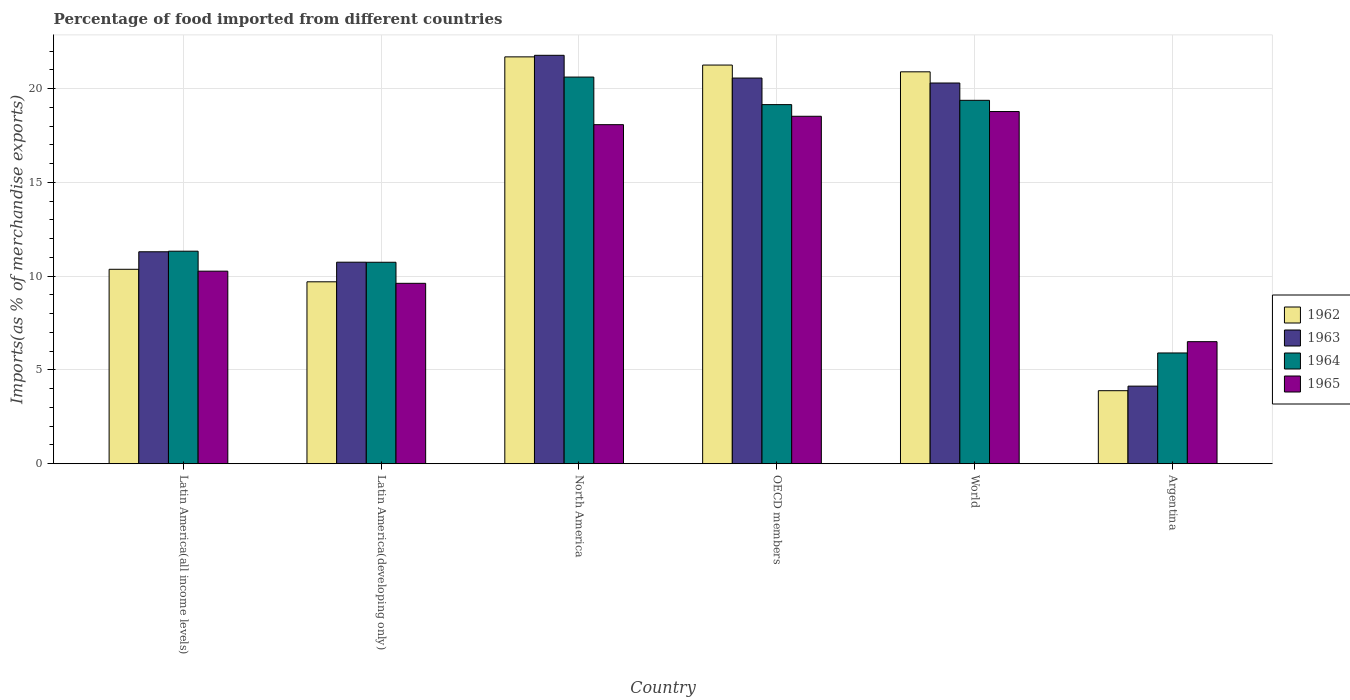How many bars are there on the 3rd tick from the left?
Make the answer very short. 4. What is the label of the 2nd group of bars from the left?
Give a very brief answer. Latin America(developing only). In how many cases, is the number of bars for a given country not equal to the number of legend labels?
Provide a short and direct response. 0. What is the percentage of imports to different countries in 1963 in North America?
Keep it short and to the point. 21.77. Across all countries, what is the maximum percentage of imports to different countries in 1965?
Give a very brief answer. 18.77. Across all countries, what is the minimum percentage of imports to different countries in 1965?
Give a very brief answer. 6.51. In which country was the percentage of imports to different countries in 1962 maximum?
Provide a short and direct response. North America. In which country was the percentage of imports to different countries in 1963 minimum?
Your answer should be compact. Argentina. What is the total percentage of imports to different countries in 1963 in the graph?
Your response must be concise. 88.8. What is the difference between the percentage of imports to different countries in 1963 in North America and that in World?
Offer a very short reply. 1.48. What is the difference between the percentage of imports to different countries in 1963 in Argentina and the percentage of imports to different countries in 1964 in OECD members?
Offer a very short reply. -15.01. What is the average percentage of imports to different countries in 1965 per country?
Give a very brief answer. 13.63. What is the difference between the percentage of imports to different countries of/in 1963 and percentage of imports to different countries of/in 1962 in OECD members?
Provide a short and direct response. -0.69. In how many countries, is the percentage of imports to different countries in 1965 greater than 12 %?
Your response must be concise. 3. What is the ratio of the percentage of imports to different countries in 1965 in Latin America(developing only) to that in World?
Offer a very short reply. 0.51. Is the difference between the percentage of imports to different countries in 1963 in Argentina and Latin America(developing only) greater than the difference between the percentage of imports to different countries in 1962 in Argentina and Latin America(developing only)?
Offer a very short reply. No. What is the difference between the highest and the second highest percentage of imports to different countries in 1965?
Your answer should be compact. -0.7. What is the difference between the highest and the lowest percentage of imports to different countries in 1965?
Ensure brevity in your answer.  12.27. Is it the case that in every country, the sum of the percentage of imports to different countries in 1962 and percentage of imports to different countries in 1965 is greater than the sum of percentage of imports to different countries in 1963 and percentage of imports to different countries in 1964?
Offer a very short reply. No. What does the 3rd bar from the left in Latin America(developing only) represents?
Make the answer very short. 1964. What does the 3rd bar from the right in Latin America(developing only) represents?
Provide a short and direct response. 1963. Is it the case that in every country, the sum of the percentage of imports to different countries in 1963 and percentage of imports to different countries in 1964 is greater than the percentage of imports to different countries in 1965?
Offer a terse response. Yes. Are all the bars in the graph horizontal?
Ensure brevity in your answer.  No. Are the values on the major ticks of Y-axis written in scientific E-notation?
Provide a short and direct response. No. How many legend labels are there?
Give a very brief answer. 4. What is the title of the graph?
Ensure brevity in your answer.  Percentage of food imported from different countries. What is the label or title of the X-axis?
Give a very brief answer. Country. What is the label or title of the Y-axis?
Ensure brevity in your answer.  Imports(as % of merchandise exports). What is the Imports(as % of merchandise exports) of 1962 in Latin America(all income levels)?
Make the answer very short. 10.36. What is the Imports(as % of merchandise exports) of 1963 in Latin America(all income levels)?
Your answer should be very brief. 11.3. What is the Imports(as % of merchandise exports) of 1964 in Latin America(all income levels)?
Provide a succinct answer. 11.33. What is the Imports(as % of merchandise exports) in 1965 in Latin America(all income levels)?
Ensure brevity in your answer.  10.26. What is the Imports(as % of merchandise exports) of 1962 in Latin America(developing only)?
Offer a very short reply. 9.7. What is the Imports(as % of merchandise exports) of 1963 in Latin America(developing only)?
Offer a terse response. 10.74. What is the Imports(as % of merchandise exports) in 1964 in Latin America(developing only)?
Keep it short and to the point. 10.74. What is the Imports(as % of merchandise exports) in 1965 in Latin America(developing only)?
Offer a terse response. 9.62. What is the Imports(as % of merchandise exports) of 1962 in North America?
Ensure brevity in your answer.  21.69. What is the Imports(as % of merchandise exports) in 1963 in North America?
Ensure brevity in your answer.  21.77. What is the Imports(as % of merchandise exports) in 1964 in North America?
Keep it short and to the point. 20.61. What is the Imports(as % of merchandise exports) in 1965 in North America?
Offer a terse response. 18.07. What is the Imports(as % of merchandise exports) in 1962 in OECD members?
Ensure brevity in your answer.  21.25. What is the Imports(as % of merchandise exports) in 1963 in OECD members?
Offer a terse response. 20.56. What is the Imports(as % of merchandise exports) of 1964 in OECD members?
Your response must be concise. 19.14. What is the Imports(as % of merchandise exports) in 1965 in OECD members?
Keep it short and to the point. 18.52. What is the Imports(as % of merchandise exports) in 1962 in World?
Provide a succinct answer. 20.89. What is the Imports(as % of merchandise exports) of 1963 in World?
Keep it short and to the point. 20.29. What is the Imports(as % of merchandise exports) of 1964 in World?
Make the answer very short. 19.37. What is the Imports(as % of merchandise exports) in 1965 in World?
Your answer should be compact. 18.77. What is the Imports(as % of merchandise exports) of 1962 in Argentina?
Make the answer very short. 3.89. What is the Imports(as % of merchandise exports) in 1963 in Argentina?
Give a very brief answer. 4.14. What is the Imports(as % of merchandise exports) in 1964 in Argentina?
Your answer should be very brief. 5.91. What is the Imports(as % of merchandise exports) of 1965 in Argentina?
Your answer should be compact. 6.51. Across all countries, what is the maximum Imports(as % of merchandise exports) in 1962?
Keep it short and to the point. 21.69. Across all countries, what is the maximum Imports(as % of merchandise exports) in 1963?
Give a very brief answer. 21.77. Across all countries, what is the maximum Imports(as % of merchandise exports) in 1964?
Provide a short and direct response. 20.61. Across all countries, what is the maximum Imports(as % of merchandise exports) of 1965?
Make the answer very short. 18.77. Across all countries, what is the minimum Imports(as % of merchandise exports) of 1962?
Give a very brief answer. 3.89. Across all countries, what is the minimum Imports(as % of merchandise exports) of 1963?
Keep it short and to the point. 4.14. Across all countries, what is the minimum Imports(as % of merchandise exports) in 1964?
Keep it short and to the point. 5.91. Across all countries, what is the minimum Imports(as % of merchandise exports) in 1965?
Offer a very short reply. 6.51. What is the total Imports(as % of merchandise exports) in 1962 in the graph?
Your response must be concise. 87.79. What is the total Imports(as % of merchandise exports) of 1963 in the graph?
Make the answer very short. 88.8. What is the total Imports(as % of merchandise exports) of 1964 in the graph?
Keep it short and to the point. 87.1. What is the total Imports(as % of merchandise exports) of 1965 in the graph?
Keep it short and to the point. 81.76. What is the difference between the Imports(as % of merchandise exports) in 1962 in Latin America(all income levels) and that in Latin America(developing only)?
Ensure brevity in your answer.  0.67. What is the difference between the Imports(as % of merchandise exports) in 1963 in Latin America(all income levels) and that in Latin America(developing only)?
Provide a short and direct response. 0.56. What is the difference between the Imports(as % of merchandise exports) in 1964 in Latin America(all income levels) and that in Latin America(developing only)?
Provide a short and direct response. 0.59. What is the difference between the Imports(as % of merchandise exports) in 1965 in Latin America(all income levels) and that in Latin America(developing only)?
Provide a short and direct response. 0.65. What is the difference between the Imports(as % of merchandise exports) in 1962 in Latin America(all income levels) and that in North America?
Your answer should be compact. -11.32. What is the difference between the Imports(as % of merchandise exports) in 1963 in Latin America(all income levels) and that in North America?
Your response must be concise. -10.47. What is the difference between the Imports(as % of merchandise exports) in 1964 in Latin America(all income levels) and that in North America?
Offer a very short reply. -9.28. What is the difference between the Imports(as % of merchandise exports) in 1965 in Latin America(all income levels) and that in North America?
Offer a terse response. -7.81. What is the difference between the Imports(as % of merchandise exports) in 1962 in Latin America(all income levels) and that in OECD members?
Ensure brevity in your answer.  -10.89. What is the difference between the Imports(as % of merchandise exports) in 1963 in Latin America(all income levels) and that in OECD members?
Your answer should be compact. -9.26. What is the difference between the Imports(as % of merchandise exports) of 1964 in Latin America(all income levels) and that in OECD members?
Ensure brevity in your answer.  -7.81. What is the difference between the Imports(as % of merchandise exports) of 1965 in Latin America(all income levels) and that in OECD members?
Offer a terse response. -8.26. What is the difference between the Imports(as % of merchandise exports) in 1962 in Latin America(all income levels) and that in World?
Provide a short and direct response. -10.53. What is the difference between the Imports(as % of merchandise exports) in 1963 in Latin America(all income levels) and that in World?
Your response must be concise. -9. What is the difference between the Imports(as % of merchandise exports) in 1964 in Latin America(all income levels) and that in World?
Your response must be concise. -8.04. What is the difference between the Imports(as % of merchandise exports) of 1965 in Latin America(all income levels) and that in World?
Make the answer very short. -8.51. What is the difference between the Imports(as % of merchandise exports) in 1962 in Latin America(all income levels) and that in Argentina?
Give a very brief answer. 6.47. What is the difference between the Imports(as % of merchandise exports) of 1963 in Latin America(all income levels) and that in Argentina?
Your answer should be compact. 7.16. What is the difference between the Imports(as % of merchandise exports) in 1964 in Latin America(all income levels) and that in Argentina?
Offer a terse response. 5.42. What is the difference between the Imports(as % of merchandise exports) in 1965 in Latin America(all income levels) and that in Argentina?
Ensure brevity in your answer.  3.76. What is the difference between the Imports(as % of merchandise exports) of 1962 in Latin America(developing only) and that in North America?
Your answer should be compact. -11.99. What is the difference between the Imports(as % of merchandise exports) of 1963 in Latin America(developing only) and that in North America?
Your response must be concise. -11.03. What is the difference between the Imports(as % of merchandise exports) of 1964 in Latin America(developing only) and that in North America?
Make the answer very short. -9.87. What is the difference between the Imports(as % of merchandise exports) in 1965 in Latin America(developing only) and that in North America?
Ensure brevity in your answer.  -8.46. What is the difference between the Imports(as % of merchandise exports) of 1962 in Latin America(developing only) and that in OECD members?
Offer a terse response. -11.55. What is the difference between the Imports(as % of merchandise exports) in 1963 in Latin America(developing only) and that in OECD members?
Provide a succinct answer. -9.82. What is the difference between the Imports(as % of merchandise exports) of 1964 in Latin America(developing only) and that in OECD members?
Offer a terse response. -8.4. What is the difference between the Imports(as % of merchandise exports) in 1965 in Latin America(developing only) and that in OECD members?
Ensure brevity in your answer.  -8.9. What is the difference between the Imports(as % of merchandise exports) of 1962 in Latin America(developing only) and that in World?
Offer a very short reply. -11.19. What is the difference between the Imports(as % of merchandise exports) in 1963 in Latin America(developing only) and that in World?
Keep it short and to the point. -9.55. What is the difference between the Imports(as % of merchandise exports) of 1964 in Latin America(developing only) and that in World?
Make the answer very short. -8.63. What is the difference between the Imports(as % of merchandise exports) of 1965 in Latin America(developing only) and that in World?
Ensure brevity in your answer.  -9.16. What is the difference between the Imports(as % of merchandise exports) of 1962 in Latin America(developing only) and that in Argentina?
Provide a short and direct response. 5.8. What is the difference between the Imports(as % of merchandise exports) of 1963 in Latin America(developing only) and that in Argentina?
Your answer should be compact. 6.61. What is the difference between the Imports(as % of merchandise exports) in 1964 in Latin America(developing only) and that in Argentina?
Ensure brevity in your answer.  4.83. What is the difference between the Imports(as % of merchandise exports) of 1965 in Latin America(developing only) and that in Argentina?
Give a very brief answer. 3.11. What is the difference between the Imports(as % of merchandise exports) in 1962 in North America and that in OECD members?
Give a very brief answer. 0.44. What is the difference between the Imports(as % of merchandise exports) in 1963 in North America and that in OECD members?
Provide a succinct answer. 1.21. What is the difference between the Imports(as % of merchandise exports) of 1964 in North America and that in OECD members?
Your answer should be very brief. 1.47. What is the difference between the Imports(as % of merchandise exports) of 1965 in North America and that in OECD members?
Provide a short and direct response. -0.45. What is the difference between the Imports(as % of merchandise exports) in 1962 in North America and that in World?
Make the answer very short. 0.8. What is the difference between the Imports(as % of merchandise exports) of 1963 in North America and that in World?
Make the answer very short. 1.48. What is the difference between the Imports(as % of merchandise exports) of 1964 in North America and that in World?
Offer a terse response. 1.24. What is the difference between the Imports(as % of merchandise exports) in 1965 in North America and that in World?
Keep it short and to the point. -0.7. What is the difference between the Imports(as % of merchandise exports) of 1962 in North America and that in Argentina?
Keep it short and to the point. 17.79. What is the difference between the Imports(as % of merchandise exports) in 1963 in North America and that in Argentina?
Make the answer very short. 17.63. What is the difference between the Imports(as % of merchandise exports) of 1964 in North America and that in Argentina?
Offer a terse response. 14.71. What is the difference between the Imports(as % of merchandise exports) in 1965 in North America and that in Argentina?
Give a very brief answer. 11.57. What is the difference between the Imports(as % of merchandise exports) in 1962 in OECD members and that in World?
Offer a very short reply. 0.36. What is the difference between the Imports(as % of merchandise exports) in 1963 in OECD members and that in World?
Keep it short and to the point. 0.26. What is the difference between the Imports(as % of merchandise exports) in 1964 in OECD members and that in World?
Provide a succinct answer. -0.23. What is the difference between the Imports(as % of merchandise exports) of 1965 in OECD members and that in World?
Keep it short and to the point. -0.25. What is the difference between the Imports(as % of merchandise exports) of 1962 in OECD members and that in Argentina?
Make the answer very short. 17.36. What is the difference between the Imports(as % of merchandise exports) in 1963 in OECD members and that in Argentina?
Ensure brevity in your answer.  16.42. What is the difference between the Imports(as % of merchandise exports) of 1964 in OECD members and that in Argentina?
Make the answer very short. 13.24. What is the difference between the Imports(as % of merchandise exports) in 1965 in OECD members and that in Argentina?
Keep it short and to the point. 12.01. What is the difference between the Imports(as % of merchandise exports) in 1962 in World and that in Argentina?
Ensure brevity in your answer.  17. What is the difference between the Imports(as % of merchandise exports) of 1963 in World and that in Argentina?
Make the answer very short. 16.16. What is the difference between the Imports(as % of merchandise exports) in 1964 in World and that in Argentina?
Provide a succinct answer. 13.47. What is the difference between the Imports(as % of merchandise exports) of 1965 in World and that in Argentina?
Provide a succinct answer. 12.27. What is the difference between the Imports(as % of merchandise exports) in 1962 in Latin America(all income levels) and the Imports(as % of merchandise exports) in 1963 in Latin America(developing only)?
Keep it short and to the point. -0.38. What is the difference between the Imports(as % of merchandise exports) of 1962 in Latin America(all income levels) and the Imports(as % of merchandise exports) of 1964 in Latin America(developing only)?
Ensure brevity in your answer.  -0.37. What is the difference between the Imports(as % of merchandise exports) in 1962 in Latin America(all income levels) and the Imports(as % of merchandise exports) in 1965 in Latin America(developing only)?
Keep it short and to the point. 0.75. What is the difference between the Imports(as % of merchandise exports) of 1963 in Latin America(all income levels) and the Imports(as % of merchandise exports) of 1964 in Latin America(developing only)?
Keep it short and to the point. 0.56. What is the difference between the Imports(as % of merchandise exports) in 1963 in Latin America(all income levels) and the Imports(as % of merchandise exports) in 1965 in Latin America(developing only)?
Keep it short and to the point. 1.68. What is the difference between the Imports(as % of merchandise exports) of 1964 in Latin America(all income levels) and the Imports(as % of merchandise exports) of 1965 in Latin America(developing only)?
Ensure brevity in your answer.  1.71. What is the difference between the Imports(as % of merchandise exports) in 1962 in Latin America(all income levels) and the Imports(as % of merchandise exports) in 1963 in North America?
Keep it short and to the point. -11.41. What is the difference between the Imports(as % of merchandise exports) in 1962 in Latin America(all income levels) and the Imports(as % of merchandise exports) in 1964 in North America?
Your response must be concise. -10.25. What is the difference between the Imports(as % of merchandise exports) of 1962 in Latin America(all income levels) and the Imports(as % of merchandise exports) of 1965 in North America?
Give a very brief answer. -7.71. What is the difference between the Imports(as % of merchandise exports) in 1963 in Latin America(all income levels) and the Imports(as % of merchandise exports) in 1964 in North America?
Your answer should be compact. -9.31. What is the difference between the Imports(as % of merchandise exports) of 1963 in Latin America(all income levels) and the Imports(as % of merchandise exports) of 1965 in North America?
Your answer should be compact. -6.78. What is the difference between the Imports(as % of merchandise exports) in 1964 in Latin America(all income levels) and the Imports(as % of merchandise exports) in 1965 in North America?
Your answer should be compact. -6.74. What is the difference between the Imports(as % of merchandise exports) in 1962 in Latin America(all income levels) and the Imports(as % of merchandise exports) in 1963 in OECD members?
Provide a short and direct response. -10.19. What is the difference between the Imports(as % of merchandise exports) in 1962 in Latin America(all income levels) and the Imports(as % of merchandise exports) in 1964 in OECD members?
Your answer should be compact. -8.78. What is the difference between the Imports(as % of merchandise exports) of 1962 in Latin America(all income levels) and the Imports(as % of merchandise exports) of 1965 in OECD members?
Provide a succinct answer. -8.16. What is the difference between the Imports(as % of merchandise exports) in 1963 in Latin America(all income levels) and the Imports(as % of merchandise exports) in 1964 in OECD members?
Offer a very short reply. -7.84. What is the difference between the Imports(as % of merchandise exports) of 1963 in Latin America(all income levels) and the Imports(as % of merchandise exports) of 1965 in OECD members?
Provide a succinct answer. -7.22. What is the difference between the Imports(as % of merchandise exports) in 1964 in Latin America(all income levels) and the Imports(as % of merchandise exports) in 1965 in OECD members?
Your answer should be compact. -7.19. What is the difference between the Imports(as % of merchandise exports) in 1962 in Latin America(all income levels) and the Imports(as % of merchandise exports) in 1963 in World?
Make the answer very short. -9.93. What is the difference between the Imports(as % of merchandise exports) in 1962 in Latin America(all income levels) and the Imports(as % of merchandise exports) in 1964 in World?
Provide a short and direct response. -9.01. What is the difference between the Imports(as % of merchandise exports) in 1962 in Latin America(all income levels) and the Imports(as % of merchandise exports) in 1965 in World?
Keep it short and to the point. -8.41. What is the difference between the Imports(as % of merchandise exports) of 1963 in Latin America(all income levels) and the Imports(as % of merchandise exports) of 1964 in World?
Give a very brief answer. -8.07. What is the difference between the Imports(as % of merchandise exports) in 1963 in Latin America(all income levels) and the Imports(as % of merchandise exports) in 1965 in World?
Offer a terse response. -7.47. What is the difference between the Imports(as % of merchandise exports) of 1964 in Latin America(all income levels) and the Imports(as % of merchandise exports) of 1965 in World?
Offer a very short reply. -7.44. What is the difference between the Imports(as % of merchandise exports) in 1962 in Latin America(all income levels) and the Imports(as % of merchandise exports) in 1963 in Argentina?
Your answer should be compact. 6.23. What is the difference between the Imports(as % of merchandise exports) of 1962 in Latin America(all income levels) and the Imports(as % of merchandise exports) of 1964 in Argentina?
Offer a terse response. 4.46. What is the difference between the Imports(as % of merchandise exports) of 1962 in Latin America(all income levels) and the Imports(as % of merchandise exports) of 1965 in Argentina?
Offer a terse response. 3.86. What is the difference between the Imports(as % of merchandise exports) of 1963 in Latin America(all income levels) and the Imports(as % of merchandise exports) of 1964 in Argentina?
Offer a terse response. 5.39. What is the difference between the Imports(as % of merchandise exports) in 1963 in Latin America(all income levels) and the Imports(as % of merchandise exports) in 1965 in Argentina?
Offer a very short reply. 4.79. What is the difference between the Imports(as % of merchandise exports) of 1964 in Latin America(all income levels) and the Imports(as % of merchandise exports) of 1965 in Argentina?
Your response must be concise. 4.82. What is the difference between the Imports(as % of merchandise exports) in 1962 in Latin America(developing only) and the Imports(as % of merchandise exports) in 1963 in North America?
Provide a succinct answer. -12.07. What is the difference between the Imports(as % of merchandise exports) in 1962 in Latin America(developing only) and the Imports(as % of merchandise exports) in 1964 in North America?
Offer a very short reply. -10.91. What is the difference between the Imports(as % of merchandise exports) of 1962 in Latin America(developing only) and the Imports(as % of merchandise exports) of 1965 in North America?
Provide a succinct answer. -8.38. What is the difference between the Imports(as % of merchandise exports) of 1963 in Latin America(developing only) and the Imports(as % of merchandise exports) of 1964 in North America?
Offer a terse response. -9.87. What is the difference between the Imports(as % of merchandise exports) of 1963 in Latin America(developing only) and the Imports(as % of merchandise exports) of 1965 in North America?
Your answer should be compact. -7.33. What is the difference between the Imports(as % of merchandise exports) of 1964 in Latin America(developing only) and the Imports(as % of merchandise exports) of 1965 in North America?
Your response must be concise. -7.33. What is the difference between the Imports(as % of merchandise exports) of 1962 in Latin America(developing only) and the Imports(as % of merchandise exports) of 1963 in OECD members?
Give a very brief answer. -10.86. What is the difference between the Imports(as % of merchandise exports) in 1962 in Latin America(developing only) and the Imports(as % of merchandise exports) in 1964 in OECD members?
Provide a succinct answer. -9.44. What is the difference between the Imports(as % of merchandise exports) of 1962 in Latin America(developing only) and the Imports(as % of merchandise exports) of 1965 in OECD members?
Provide a short and direct response. -8.82. What is the difference between the Imports(as % of merchandise exports) in 1963 in Latin America(developing only) and the Imports(as % of merchandise exports) in 1964 in OECD members?
Offer a terse response. -8.4. What is the difference between the Imports(as % of merchandise exports) of 1963 in Latin America(developing only) and the Imports(as % of merchandise exports) of 1965 in OECD members?
Your answer should be compact. -7.78. What is the difference between the Imports(as % of merchandise exports) of 1964 in Latin America(developing only) and the Imports(as % of merchandise exports) of 1965 in OECD members?
Offer a terse response. -7.78. What is the difference between the Imports(as % of merchandise exports) of 1962 in Latin America(developing only) and the Imports(as % of merchandise exports) of 1963 in World?
Make the answer very short. -10.6. What is the difference between the Imports(as % of merchandise exports) in 1962 in Latin America(developing only) and the Imports(as % of merchandise exports) in 1964 in World?
Provide a succinct answer. -9.67. What is the difference between the Imports(as % of merchandise exports) of 1962 in Latin America(developing only) and the Imports(as % of merchandise exports) of 1965 in World?
Offer a terse response. -9.08. What is the difference between the Imports(as % of merchandise exports) of 1963 in Latin America(developing only) and the Imports(as % of merchandise exports) of 1964 in World?
Make the answer very short. -8.63. What is the difference between the Imports(as % of merchandise exports) in 1963 in Latin America(developing only) and the Imports(as % of merchandise exports) in 1965 in World?
Keep it short and to the point. -8.03. What is the difference between the Imports(as % of merchandise exports) of 1964 in Latin America(developing only) and the Imports(as % of merchandise exports) of 1965 in World?
Offer a very short reply. -8.03. What is the difference between the Imports(as % of merchandise exports) in 1962 in Latin America(developing only) and the Imports(as % of merchandise exports) in 1963 in Argentina?
Ensure brevity in your answer.  5.56. What is the difference between the Imports(as % of merchandise exports) of 1962 in Latin America(developing only) and the Imports(as % of merchandise exports) of 1964 in Argentina?
Your answer should be very brief. 3.79. What is the difference between the Imports(as % of merchandise exports) of 1962 in Latin America(developing only) and the Imports(as % of merchandise exports) of 1965 in Argentina?
Ensure brevity in your answer.  3.19. What is the difference between the Imports(as % of merchandise exports) of 1963 in Latin America(developing only) and the Imports(as % of merchandise exports) of 1964 in Argentina?
Keep it short and to the point. 4.84. What is the difference between the Imports(as % of merchandise exports) of 1963 in Latin America(developing only) and the Imports(as % of merchandise exports) of 1965 in Argentina?
Offer a very short reply. 4.24. What is the difference between the Imports(as % of merchandise exports) in 1964 in Latin America(developing only) and the Imports(as % of merchandise exports) in 1965 in Argentina?
Provide a succinct answer. 4.23. What is the difference between the Imports(as % of merchandise exports) of 1962 in North America and the Imports(as % of merchandise exports) of 1963 in OECD members?
Your answer should be very brief. 1.13. What is the difference between the Imports(as % of merchandise exports) in 1962 in North America and the Imports(as % of merchandise exports) in 1964 in OECD members?
Your answer should be compact. 2.55. What is the difference between the Imports(as % of merchandise exports) of 1962 in North America and the Imports(as % of merchandise exports) of 1965 in OECD members?
Ensure brevity in your answer.  3.17. What is the difference between the Imports(as % of merchandise exports) of 1963 in North America and the Imports(as % of merchandise exports) of 1964 in OECD members?
Provide a succinct answer. 2.63. What is the difference between the Imports(as % of merchandise exports) of 1963 in North America and the Imports(as % of merchandise exports) of 1965 in OECD members?
Provide a short and direct response. 3.25. What is the difference between the Imports(as % of merchandise exports) of 1964 in North America and the Imports(as % of merchandise exports) of 1965 in OECD members?
Provide a succinct answer. 2.09. What is the difference between the Imports(as % of merchandise exports) in 1962 in North America and the Imports(as % of merchandise exports) in 1963 in World?
Give a very brief answer. 1.39. What is the difference between the Imports(as % of merchandise exports) in 1962 in North America and the Imports(as % of merchandise exports) in 1964 in World?
Keep it short and to the point. 2.32. What is the difference between the Imports(as % of merchandise exports) of 1962 in North America and the Imports(as % of merchandise exports) of 1965 in World?
Offer a very short reply. 2.91. What is the difference between the Imports(as % of merchandise exports) in 1963 in North America and the Imports(as % of merchandise exports) in 1964 in World?
Provide a succinct answer. 2.4. What is the difference between the Imports(as % of merchandise exports) in 1963 in North America and the Imports(as % of merchandise exports) in 1965 in World?
Make the answer very short. 3. What is the difference between the Imports(as % of merchandise exports) of 1964 in North America and the Imports(as % of merchandise exports) of 1965 in World?
Offer a very short reply. 1.84. What is the difference between the Imports(as % of merchandise exports) of 1962 in North America and the Imports(as % of merchandise exports) of 1963 in Argentina?
Give a very brief answer. 17.55. What is the difference between the Imports(as % of merchandise exports) of 1962 in North America and the Imports(as % of merchandise exports) of 1964 in Argentina?
Provide a succinct answer. 15.78. What is the difference between the Imports(as % of merchandise exports) in 1962 in North America and the Imports(as % of merchandise exports) in 1965 in Argentina?
Provide a succinct answer. 15.18. What is the difference between the Imports(as % of merchandise exports) in 1963 in North America and the Imports(as % of merchandise exports) in 1964 in Argentina?
Ensure brevity in your answer.  15.87. What is the difference between the Imports(as % of merchandise exports) in 1963 in North America and the Imports(as % of merchandise exports) in 1965 in Argentina?
Offer a very short reply. 15.26. What is the difference between the Imports(as % of merchandise exports) of 1964 in North America and the Imports(as % of merchandise exports) of 1965 in Argentina?
Provide a succinct answer. 14.1. What is the difference between the Imports(as % of merchandise exports) in 1962 in OECD members and the Imports(as % of merchandise exports) in 1963 in World?
Your answer should be very brief. 0.96. What is the difference between the Imports(as % of merchandise exports) in 1962 in OECD members and the Imports(as % of merchandise exports) in 1964 in World?
Your answer should be compact. 1.88. What is the difference between the Imports(as % of merchandise exports) in 1962 in OECD members and the Imports(as % of merchandise exports) in 1965 in World?
Provide a succinct answer. 2.48. What is the difference between the Imports(as % of merchandise exports) of 1963 in OECD members and the Imports(as % of merchandise exports) of 1964 in World?
Provide a short and direct response. 1.19. What is the difference between the Imports(as % of merchandise exports) of 1963 in OECD members and the Imports(as % of merchandise exports) of 1965 in World?
Ensure brevity in your answer.  1.78. What is the difference between the Imports(as % of merchandise exports) of 1964 in OECD members and the Imports(as % of merchandise exports) of 1965 in World?
Provide a short and direct response. 0.37. What is the difference between the Imports(as % of merchandise exports) of 1962 in OECD members and the Imports(as % of merchandise exports) of 1963 in Argentina?
Offer a very short reply. 17.11. What is the difference between the Imports(as % of merchandise exports) of 1962 in OECD members and the Imports(as % of merchandise exports) of 1964 in Argentina?
Provide a succinct answer. 15.35. What is the difference between the Imports(as % of merchandise exports) of 1962 in OECD members and the Imports(as % of merchandise exports) of 1965 in Argentina?
Ensure brevity in your answer.  14.74. What is the difference between the Imports(as % of merchandise exports) of 1963 in OECD members and the Imports(as % of merchandise exports) of 1964 in Argentina?
Give a very brief answer. 14.65. What is the difference between the Imports(as % of merchandise exports) of 1963 in OECD members and the Imports(as % of merchandise exports) of 1965 in Argentina?
Keep it short and to the point. 14.05. What is the difference between the Imports(as % of merchandise exports) in 1964 in OECD members and the Imports(as % of merchandise exports) in 1965 in Argentina?
Ensure brevity in your answer.  12.64. What is the difference between the Imports(as % of merchandise exports) of 1962 in World and the Imports(as % of merchandise exports) of 1963 in Argentina?
Your answer should be compact. 16.75. What is the difference between the Imports(as % of merchandise exports) of 1962 in World and the Imports(as % of merchandise exports) of 1964 in Argentina?
Your response must be concise. 14.99. What is the difference between the Imports(as % of merchandise exports) in 1962 in World and the Imports(as % of merchandise exports) in 1965 in Argentina?
Offer a very short reply. 14.38. What is the difference between the Imports(as % of merchandise exports) of 1963 in World and the Imports(as % of merchandise exports) of 1964 in Argentina?
Provide a short and direct response. 14.39. What is the difference between the Imports(as % of merchandise exports) in 1963 in World and the Imports(as % of merchandise exports) in 1965 in Argentina?
Your response must be concise. 13.79. What is the difference between the Imports(as % of merchandise exports) in 1964 in World and the Imports(as % of merchandise exports) in 1965 in Argentina?
Keep it short and to the point. 12.86. What is the average Imports(as % of merchandise exports) of 1962 per country?
Your response must be concise. 14.63. What is the average Imports(as % of merchandise exports) of 1963 per country?
Provide a succinct answer. 14.8. What is the average Imports(as % of merchandise exports) of 1964 per country?
Your answer should be compact. 14.52. What is the average Imports(as % of merchandise exports) in 1965 per country?
Your answer should be compact. 13.63. What is the difference between the Imports(as % of merchandise exports) in 1962 and Imports(as % of merchandise exports) in 1963 in Latin America(all income levels)?
Keep it short and to the point. -0.93. What is the difference between the Imports(as % of merchandise exports) in 1962 and Imports(as % of merchandise exports) in 1964 in Latin America(all income levels)?
Your answer should be very brief. -0.96. What is the difference between the Imports(as % of merchandise exports) in 1962 and Imports(as % of merchandise exports) in 1965 in Latin America(all income levels)?
Give a very brief answer. 0.1. What is the difference between the Imports(as % of merchandise exports) of 1963 and Imports(as % of merchandise exports) of 1964 in Latin America(all income levels)?
Provide a succinct answer. -0.03. What is the difference between the Imports(as % of merchandise exports) in 1963 and Imports(as % of merchandise exports) in 1965 in Latin America(all income levels)?
Offer a very short reply. 1.03. What is the difference between the Imports(as % of merchandise exports) in 1964 and Imports(as % of merchandise exports) in 1965 in Latin America(all income levels)?
Provide a succinct answer. 1.07. What is the difference between the Imports(as % of merchandise exports) in 1962 and Imports(as % of merchandise exports) in 1963 in Latin America(developing only)?
Keep it short and to the point. -1.05. What is the difference between the Imports(as % of merchandise exports) of 1962 and Imports(as % of merchandise exports) of 1964 in Latin America(developing only)?
Your answer should be very brief. -1.04. What is the difference between the Imports(as % of merchandise exports) of 1962 and Imports(as % of merchandise exports) of 1965 in Latin America(developing only)?
Give a very brief answer. 0.08. What is the difference between the Imports(as % of merchandise exports) in 1963 and Imports(as % of merchandise exports) in 1964 in Latin America(developing only)?
Your response must be concise. 0. What is the difference between the Imports(as % of merchandise exports) in 1963 and Imports(as % of merchandise exports) in 1965 in Latin America(developing only)?
Give a very brief answer. 1.13. What is the difference between the Imports(as % of merchandise exports) of 1964 and Imports(as % of merchandise exports) of 1965 in Latin America(developing only)?
Make the answer very short. 1.12. What is the difference between the Imports(as % of merchandise exports) in 1962 and Imports(as % of merchandise exports) in 1963 in North America?
Ensure brevity in your answer.  -0.08. What is the difference between the Imports(as % of merchandise exports) in 1962 and Imports(as % of merchandise exports) in 1964 in North America?
Your response must be concise. 1.08. What is the difference between the Imports(as % of merchandise exports) in 1962 and Imports(as % of merchandise exports) in 1965 in North America?
Keep it short and to the point. 3.61. What is the difference between the Imports(as % of merchandise exports) of 1963 and Imports(as % of merchandise exports) of 1964 in North America?
Ensure brevity in your answer.  1.16. What is the difference between the Imports(as % of merchandise exports) in 1963 and Imports(as % of merchandise exports) in 1965 in North America?
Your response must be concise. 3.7. What is the difference between the Imports(as % of merchandise exports) of 1964 and Imports(as % of merchandise exports) of 1965 in North America?
Offer a terse response. 2.54. What is the difference between the Imports(as % of merchandise exports) of 1962 and Imports(as % of merchandise exports) of 1963 in OECD members?
Your response must be concise. 0.69. What is the difference between the Imports(as % of merchandise exports) of 1962 and Imports(as % of merchandise exports) of 1964 in OECD members?
Provide a short and direct response. 2.11. What is the difference between the Imports(as % of merchandise exports) in 1962 and Imports(as % of merchandise exports) in 1965 in OECD members?
Make the answer very short. 2.73. What is the difference between the Imports(as % of merchandise exports) of 1963 and Imports(as % of merchandise exports) of 1964 in OECD members?
Provide a succinct answer. 1.42. What is the difference between the Imports(as % of merchandise exports) of 1963 and Imports(as % of merchandise exports) of 1965 in OECD members?
Offer a very short reply. 2.04. What is the difference between the Imports(as % of merchandise exports) in 1964 and Imports(as % of merchandise exports) in 1965 in OECD members?
Your answer should be compact. 0.62. What is the difference between the Imports(as % of merchandise exports) in 1962 and Imports(as % of merchandise exports) in 1963 in World?
Your answer should be very brief. 0.6. What is the difference between the Imports(as % of merchandise exports) of 1962 and Imports(as % of merchandise exports) of 1964 in World?
Your answer should be compact. 1.52. What is the difference between the Imports(as % of merchandise exports) of 1962 and Imports(as % of merchandise exports) of 1965 in World?
Ensure brevity in your answer.  2.12. What is the difference between the Imports(as % of merchandise exports) of 1963 and Imports(as % of merchandise exports) of 1964 in World?
Ensure brevity in your answer.  0.92. What is the difference between the Imports(as % of merchandise exports) of 1963 and Imports(as % of merchandise exports) of 1965 in World?
Your answer should be compact. 1.52. What is the difference between the Imports(as % of merchandise exports) in 1964 and Imports(as % of merchandise exports) in 1965 in World?
Your answer should be very brief. 0.6. What is the difference between the Imports(as % of merchandise exports) in 1962 and Imports(as % of merchandise exports) in 1963 in Argentina?
Keep it short and to the point. -0.24. What is the difference between the Imports(as % of merchandise exports) in 1962 and Imports(as % of merchandise exports) in 1964 in Argentina?
Your answer should be very brief. -2.01. What is the difference between the Imports(as % of merchandise exports) in 1962 and Imports(as % of merchandise exports) in 1965 in Argentina?
Your answer should be compact. -2.61. What is the difference between the Imports(as % of merchandise exports) of 1963 and Imports(as % of merchandise exports) of 1964 in Argentina?
Your answer should be compact. -1.77. What is the difference between the Imports(as % of merchandise exports) in 1963 and Imports(as % of merchandise exports) in 1965 in Argentina?
Your response must be concise. -2.37. What is the difference between the Imports(as % of merchandise exports) of 1964 and Imports(as % of merchandise exports) of 1965 in Argentina?
Give a very brief answer. -0.6. What is the ratio of the Imports(as % of merchandise exports) in 1962 in Latin America(all income levels) to that in Latin America(developing only)?
Your answer should be very brief. 1.07. What is the ratio of the Imports(as % of merchandise exports) of 1963 in Latin America(all income levels) to that in Latin America(developing only)?
Offer a very short reply. 1.05. What is the ratio of the Imports(as % of merchandise exports) of 1964 in Latin America(all income levels) to that in Latin America(developing only)?
Your response must be concise. 1.05. What is the ratio of the Imports(as % of merchandise exports) of 1965 in Latin America(all income levels) to that in Latin America(developing only)?
Provide a succinct answer. 1.07. What is the ratio of the Imports(as % of merchandise exports) of 1962 in Latin America(all income levels) to that in North America?
Keep it short and to the point. 0.48. What is the ratio of the Imports(as % of merchandise exports) in 1963 in Latin America(all income levels) to that in North America?
Ensure brevity in your answer.  0.52. What is the ratio of the Imports(as % of merchandise exports) of 1964 in Latin America(all income levels) to that in North America?
Offer a terse response. 0.55. What is the ratio of the Imports(as % of merchandise exports) of 1965 in Latin America(all income levels) to that in North America?
Offer a very short reply. 0.57. What is the ratio of the Imports(as % of merchandise exports) of 1962 in Latin America(all income levels) to that in OECD members?
Your answer should be very brief. 0.49. What is the ratio of the Imports(as % of merchandise exports) of 1963 in Latin America(all income levels) to that in OECD members?
Offer a terse response. 0.55. What is the ratio of the Imports(as % of merchandise exports) of 1964 in Latin America(all income levels) to that in OECD members?
Your answer should be compact. 0.59. What is the ratio of the Imports(as % of merchandise exports) in 1965 in Latin America(all income levels) to that in OECD members?
Provide a succinct answer. 0.55. What is the ratio of the Imports(as % of merchandise exports) in 1962 in Latin America(all income levels) to that in World?
Provide a short and direct response. 0.5. What is the ratio of the Imports(as % of merchandise exports) in 1963 in Latin America(all income levels) to that in World?
Ensure brevity in your answer.  0.56. What is the ratio of the Imports(as % of merchandise exports) in 1964 in Latin America(all income levels) to that in World?
Your response must be concise. 0.58. What is the ratio of the Imports(as % of merchandise exports) of 1965 in Latin America(all income levels) to that in World?
Your answer should be very brief. 0.55. What is the ratio of the Imports(as % of merchandise exports) of 1962 in Latin America(all income levels) to that in Argentina?
Your response must be concise. 2.66. What is the ratio of the Imports(as % of merchandise exports) in 1963 in Latin America(all income levels) to that in Argentina?
Your answer should be compact. 2.73. What is the ratio of the Imports(as % of merchandise exports) in 1964 in Latin America(all income levels) to that in Argentina?
Make the answer very short. 1.92. What is the ratio of the Imports(as % of merchandise exports) of 1965 in Latin America(all income levels) to that in Argentina?
Ensure brevity in your answer.  1.58. What is the ratio of the Imports(as % of merchandise exports) of 1962 in Latin America(developing only) to that in North America?
Your answer should be compact. 0.45. What is the ratio of the Imports(as % of merchandise exports) of 1963 in Latin America(developing only) to that in North America?
Offer a very short reply. 0.49. What is the ratio of the Imports(as % of merchandise exports) of 1964 in Latin America(developing only) to that in North America?
Provide a short and direct response. 0.52. What is the ratio of the Imports(as % of merchandise exports) of 1965 in Latin America(developing only) to that in North America?
Provide a short and direct response. 0.53. What is the ratio of the Imports(as % of merchandise exports) of 1962 in Latin America(developing only) to that in OECD members?
Your answer should be compact. 0.46. What is the ratio of the Imports(as % of merchandise exports) of 1963 in Latin America(developing only) to that in OECD members?
Offer a very short reply. 0.52. What is the ratio of the Imports(as % of merchandise exports) of 1964 in Latin America(developing only) to that in OECD members?
Make the answer very short. 0.56. What is the ratio of the Imports(as % of merchandise exports) of 1965 in Latin America(developing only) to that in OECD members?
Give a very brief answer. 0.52. What is the ratio of the Imports(as % of merchandise exports) of 1962 in Latin America(developing only) to that in World?
Your answer should be very brief. 0.46. What is the ratio of the Imports(as % of merchandise exports) of 1963 in Latin America(developing only) to that in World?
Offer a very short reply. 0.53. What is the ratio of the Imports(as % of merchandise exports) of 1964 in Latin America(developing only) to that in World?
Offer a terse response. 0.55. What is the ratio of the Imports(as % of merchandise exports) of 1965 in Latin America(developing only) to that in World?
Your answer should be very brief. 0.51. What is the ratio of the Imports(as % of merchandise exports) in 1962 in Latin America(developing only) to that in Argentina?
Your answer should be very brief. 2.49. What is the ratio of the Imports(as % of merchandise exports) in 1963 in Latin America(developing only) to that in Argentina?
Ensure brevity in your answer.  2.6. What is the ratio of the Imports(as % of merchandise exports) of 1964 in Latin America(developing only) to that in Argentina?
Your response must be concise. 1.82. What is the ratio of the Imports(as % of merchandise exports) of 1965 in Latin America(developing only) to that in Argentina?
Provide a succinct answer. 1.48. What is the ratio of the Imports(as % of merchandise exports) in 1962 in North America to that in OECD members?
Make the answer very short. 1.02. What is the ratio of the Imports(as % of merchandise exports) in 1963 in North America to that in OECD members?
Offer a terse response. 1.06. What is the ratio of the Imports(as % of merchandise exports) of 1964 in North America to that in OECD members?
Your answer should be very brief. 1.08. What is the ratio of the Imports(as % of merchandise exports) in 1965 in North America to that in OECD members?
Ensure brevity in your answer.  0.98. What is the ratio of the Imports(as % of merchandise exports) in 1962 in North America to that in World?
Offer a terse response. 1.04. What is the ratio of the Imports(as % of merchandise exports) in 1963 in North America to that in World?
Offer a terse response. 1.07. What is the ratio of the Imports(as % of merchandise exports) of 1964 in North America to that in World?
Give a very brief answer. 1.06. What is the ratio of the Imports(as % of merchandise exports) in 1965 in North America to that in World?
Offer a very short reply. 0.96. What is the ratio of the Imports(as % of merchandise exports) of 1962 in North America to that in Argentina?
Provide a succinct answer. 5.57. What is the ratio of the Imports(as % of merchandise exports) of 1963 in North America to that in Argentina?
Offer a very short reply. 5.26. What is the ratio of the Imports(as % of merchandise exports) in 1964 in North America to that in Argentina?
Offer a terse response. 3.49. What is the ratio of the Imports(as % of merchandise exports) in 1965 in North America to that in Argentina?
Keep it short and to the point. 2.78. What is the ratio of the Imports(as % of merchandise exports) of 1962 in OECD members to that in World?
Provide a short and direct response. 1.02. What is the ratio of the Imports(as % of merchandise exports) in 1964 in OECD members to that in World?
Your answer should be compact. 0.99. What is the ratio of the Imports(as % of merchandise exports) in 1965 in OECD members to that in World?
Offer a very short reply. 0.99. What is the ratio of the Imports(as % of merchandise exports) in 1962 in OECD members to that in Argentina?
Offer a terse response. 5.46. What is the ratio of the Imports(as % of merchandise exports) of 1963 in OECD members to that in Argentina?
Provide a succinct answer. 4.97. What is the ratio of the Imports(as % of merchandise exports) of 1964 in OECD members to that in Argentina?
Offer a terse response. 3.24. What is the ratio of the Imports(as % of merchandise exports) of 1965 in OECD members to that in Argentina?
Your answer should be very brief. 2.85. What is the ratio of the Imports(as % of merchandise exports) of 1962 in World to that in Argentina?
Give a very brief answer. 5.37. What is the ratio of the Imports(as % of merchandise exports) of 1963 in World to that in Argentina?
Ensure brevity in your answer.  4.91. What is the ratio of the Imports(as % of merchandise exports) in 1964 in World to that in Argentina?
Ensure brevity in your answer.  3.28. What is the ratio of the Imports(as % of merchandise exports) in 1965 in World to that in Argentina?
Offer a terse response. 2.89. What is the difference between the highest and the second highest Imports(as % of merchandise exports) of 1962?
Provide a short and direct response. 0.44. What is the difference between the highest and the second highest Imports(as % of merchandise exports) in 1963?
Your answer should be very brief. 1.21. What is the difference between the highest and the second highest Imports(as % of merchandise exports) in 1964?
Your answer should be compact. 1.24. What is the difference between the highest and the second highest Imports(as % of merchandise exports) in 1965?
Offer a very short reply. 0.25. What is the difference between the highest and the lowest Imports(as % of merchandise exports) of 1962?
Provide a short and direct response. 17.79. What is the difference between the highest and the lowest Imports(as % of merchandise exports) of 1963?
Offer a terse response. 17.63. What is the difference between the highest and the lowest Imports(as % of merchandise exports) of 1964?
Give a very brief answer. 14.71. What is the difference between the highest and the lowest Imports(as % of merchandise exports) in 1965?
Your answer should be compact. 12.27. 